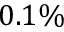<formula> <loc_0><loc_0><loc_500><loc_500>0 . 1 \%</formula> 